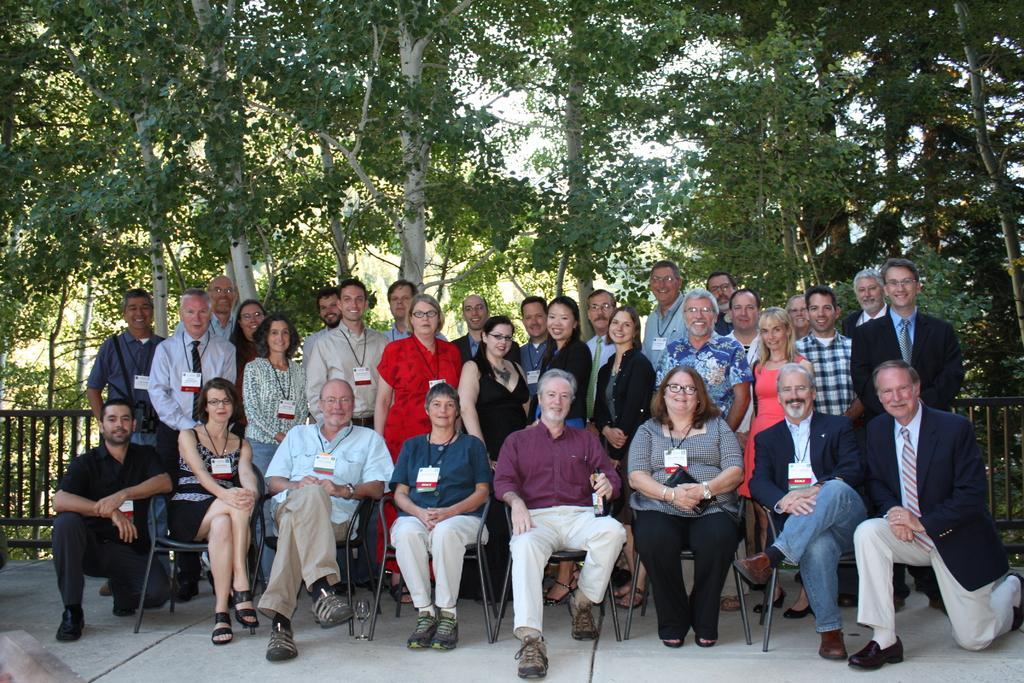Can you describe this image briefly? In this picture we can see group of people, few are sitting on the chairs and few are standing, behind them we can see fence and trees. 